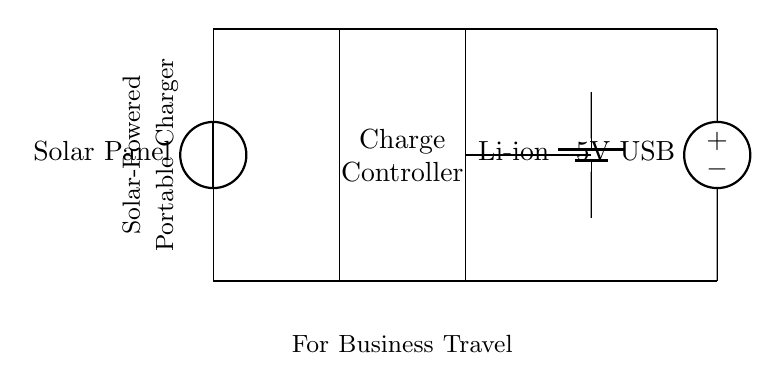What is the primary power source of this charger? The primary power source is a solar panel located at the top left of the diagram, which generates electrical energy from sunlight.
Answer: Solar Panel What type of battery is used in this circuit? The circuit diagram shows a lithium-ion battery, indicated by the symbol labeled as "Li-ion" on the right side.
Answer: Li-ion What is the output voltage of this portable charger? The output voltage is 5V, which is specified on the American voltage source on the far right side of the diagram.
Answer: 5V How many main components are visible in the circuit? There are four main components visible: a solar panel, a charge controller, a lithium-ion battery, and a USB output.
Answer: Four What is the function of the charge controller in this circuit? The charge controller regulates the voltage and current flowing from the solar panel to the battery, ensuring safe and efficient charging.
Answer: Regulates charging What is the connection between the charge controller and the battery? The charge controller is connected to the battery via a direct wire, allowing power to flow from the charge controller to charge the battery.
Answer: Direct wire connection What is the overall purpose of this circuit? The overall purpose of the circuit is to provide a means of charging portable electronic devices using solar energy while traveling for business.
Answer: Solar charging 